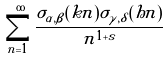<formula> <loc_0><loc_0><loc_500><loc_500>\sum _ { n = 1 } ^ { \infty } \frac { \sigma _ { \alpha , \beta } ( k n ) \sigma _ { \gamma , \delta } ( h n ) } { n ^ { 1 + s } }</formula> 